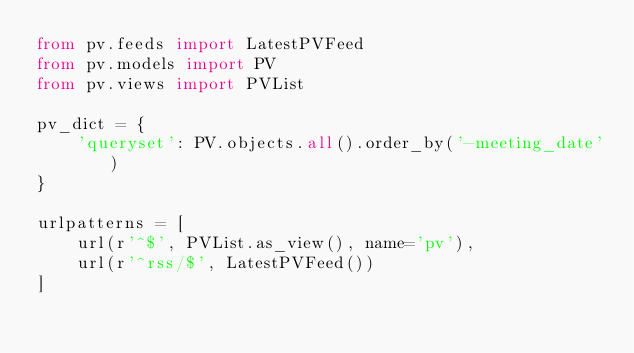<code> <loc_0><loc_0><loc_500><loc_500><_Python_>from pv.feeds import LatestPVFeed
from pv.models import PV
from pv.views import PVList

pv_dict = {
    'queryset': PV.objects.all().order_by('-meeting_date')
}

urlpatterns = [
    url(r'^$', PVList.as_view(), name='pv'),
    url(r'^rss/$', LatestPVFeed())
]
</code> 